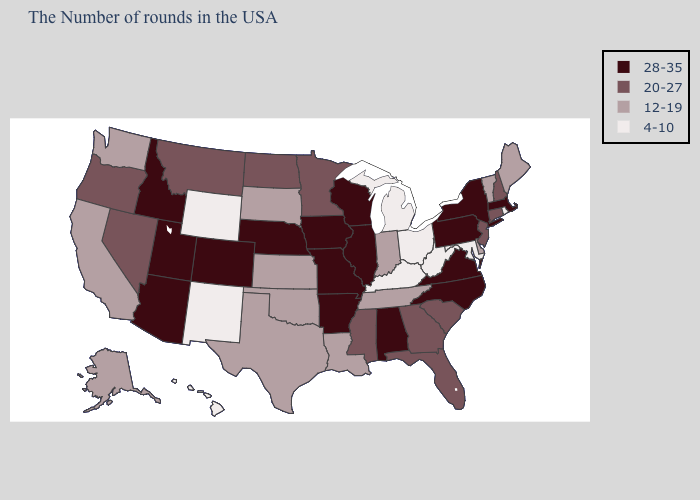Which states have the lowest value in the South?
Concise answer only. Maryland, West Virginia, Kentucky. Name the states that have a value in the range 4-10?
Keep it brief. Rhode Island, Maryland, West Virginia, Ohio, Michigan, Kentucky, Wyoming, New Mexico, Hawaii. What is the value of New Mexico?
Keep it brief. 4-10. Does Washington have a higher value than Kentucky?
Write a very short answer. Yes. Which states have the highest value in the USA?
Be succinct. Massachusetts, New York, Pennsylvania, Virginia, North Carolina, Alabama, Wisconsin, Illinois, Missouri, Arkansas, Iowa, Nebraska, Colorado, Utah, Arizona, Idaho. What is the lowest value in states that border Colorado?
Quick response, please. 4-10. Which states have the highest value in the USA?
Answer briefly. Massachusetts, New York, Pennsylvania, Virginia, North Carolina, Alabama, Wisconsin, Illinois, Missouri, Arkansas, Iowa, Nebraska, Colorado, Utah, Arizona, Idaho. What is the value of Pennsylvania?
Be succinct. 28-35. What is the value of Hawaii?
Answer briefly. 4-10. Which states have the highest value in the USA?
Short answer required. Massachusetts, New York, Pennsylvania, Virginia, North Carolina, Alabama, Wisconsin, Illinois, Missouri, Arkansas, Iowa, Nebraska, Colorado, Utah, Arizona, Idaho. What is the highest value in the USA?
Answer briefly. 28-35. Does Mississippi have a lower value than New Hampshire?
Short answer required. No. What is the lowest value in states that border Michigan?
Give a very brief answer. 4-10. Does the map have missing data?
Concise answer only. No. Name the states that have a value in the range 20-27?
Answer briefly. New Hampshire, Connecticut, New Jersey, South Carolina, Florida, Georgia, Mississippi, Minnesota, North Dakota, Montana, Nevada, Oregon. 